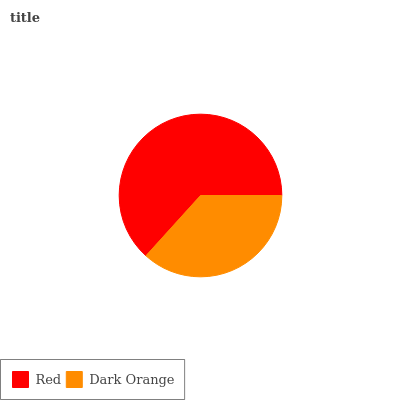Is Dark Orange the minimum?
Answer yes or no. Yes. Is Red the maximum?
Answer yes or no. Yes. Is Dark Orange the maximum?
Answer yes or no. No. Is Red greater than Dark Orange?
Answer yes or no. Yes. Is Dark Orange less than Red?
Answer yes or no. Yes. Is Dark Orange greater than Red?
Answer yes or no. No. Is Red less than Dark Orange?
Answer yes or no. No. Is Red the high median?
Answer yes or no. Yes. Is Dark Orange the low median?
Answer yes or no. Yes. Is Dark Orange the high median?
Answer yes or no. No. Is Red the low median?
Answer yes or no. No. 